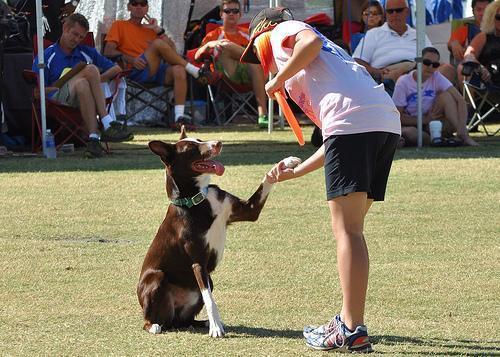How many dogs are there?
Give a very brief answer. 1. How many people are wearing orange shirts?
Give a very brief answer. 3. How many women are wearing hats?
Give a very brief answer. 1. How many people are sitting on the ground?
Give a very brief answer. 1. How many dogs are shown?
Give a very brief answer. 1. How many men are wearing sunglasses and orange shirts?
Give a very brief answer. 2. 